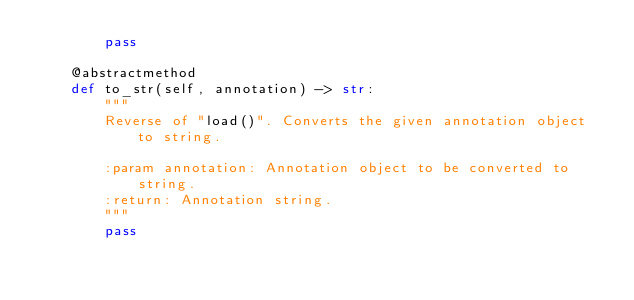Convert code to text. <code><loc_0><loc_0><loc_500><loc_500><_Python_>        pass

    @abstractmethod
    def to_str(self, annotation) -> str:
        """
        Reverse of "load()". Converts the given annotation object to string.

        :param annotation: Annotation object to be converted to string.
        :return: Annotation string.
        """
        pass
</code> 